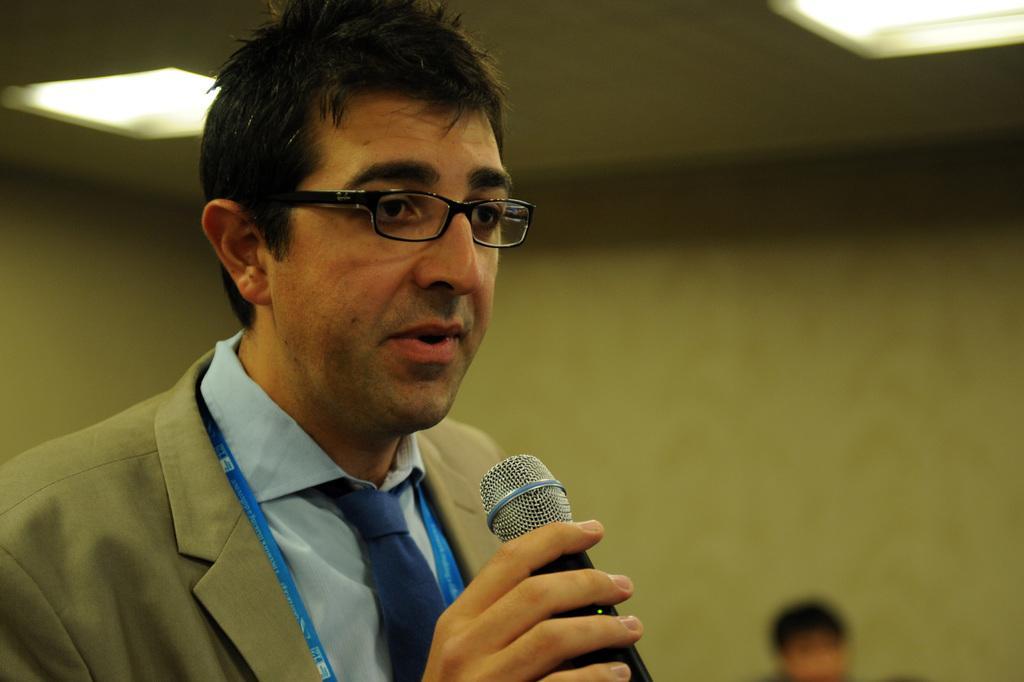Describe this image in one or two sentences. In this picture is a there is a man standing and speaking, he is looking at someone else and he is holding the microphone with his right hand and is wearing a jacket and on to his left is there is another person sitting and there is a wall and the ceiling has lights attached to it. 